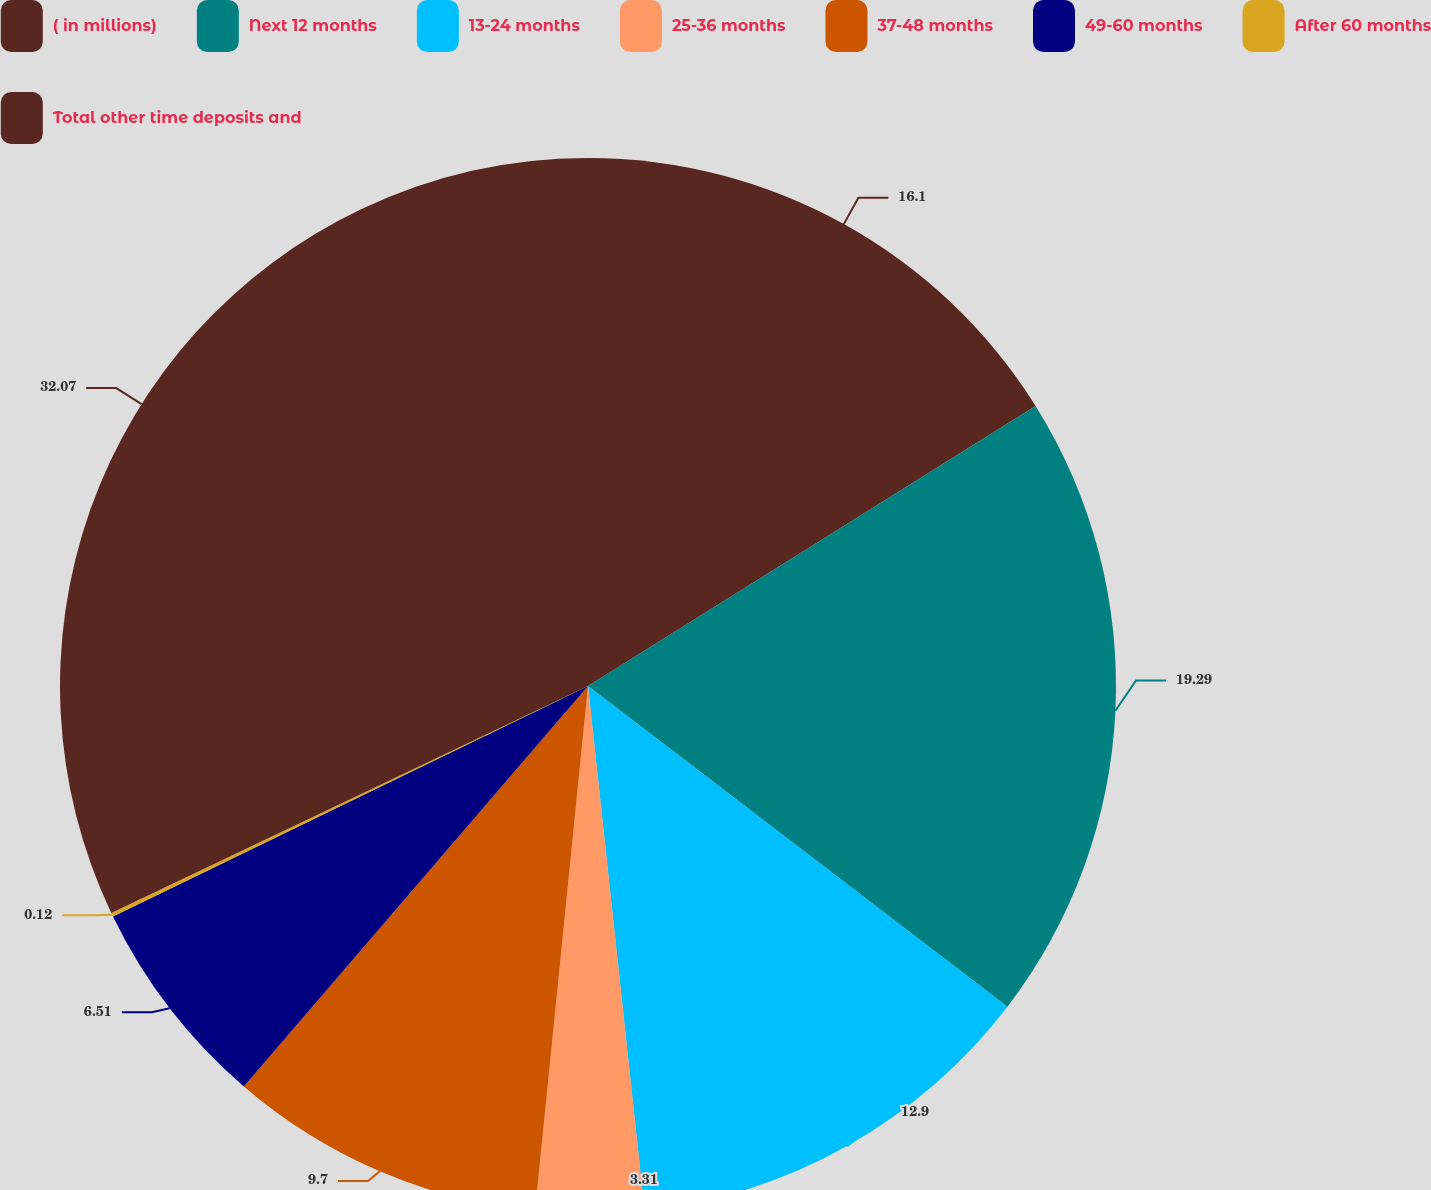<chart> <loc_0><loc_0><loc_500><loc_500><pie_chart><fcel>( in millions)<fcel>Next 12 months<fcel>13-24 months<fcel>25-36 months<fcel>37-48 months<fcel>49-60 months<fcel>After 60 months<fcel>Total other time deposits and<nl><fcel>16.1%<fcel>19.29%<fcel>12.9%<fcel>3.31%<fcel>9.7%<fcel>6.51%<fcel>0.12%<fcel>32.07%<nl></chart> 